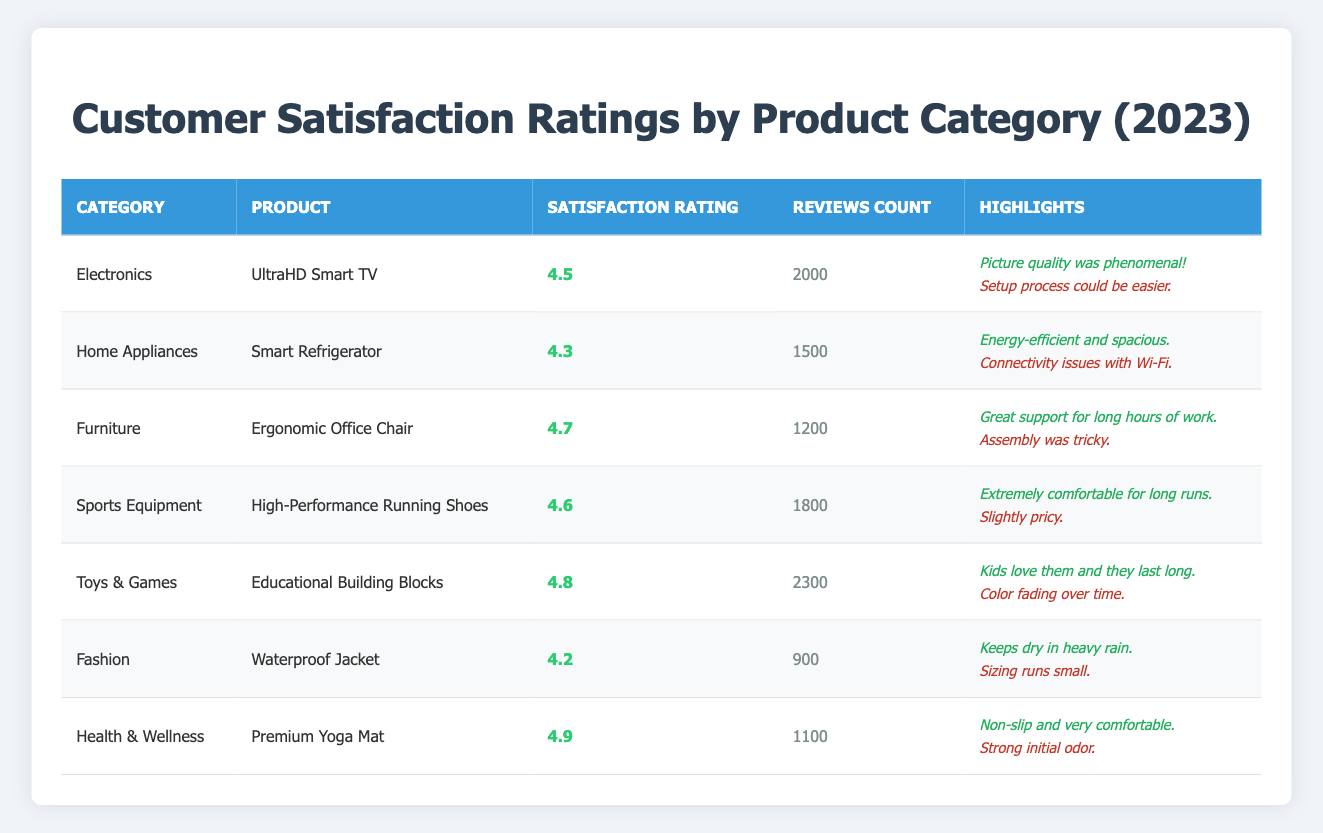What is the highest satisfaction rating among the products? The satisfaction ratings for the products are 4.5, 4.3, 4.7, 4.6, 4.8, 4.2, and 4.9. The highest of these is 4.9 for the Premium Yoga Mat.
Answer: 4.9 Which product has the lowest number of reviews? Looking at the Reviews Count column, the Waterproof Jacket has the lowest count with 900 reviews.
Answer: 900 What is the average satisfaction rating for all products? The satisfaction ratings are 4.5, 4.3, 4.7, 4.6, 4.8, 4.2, and 4.9. Summing these ratings gives 4.5 + 4.3 + 4.7 + 4.6 + 4.8 + 4.2 + 4.9 = 33.0. There are 7 ratings, so the average is 33.0 / 7 = 4.71.
Answer: 4.71 How many products have a satisfaction rating above 4.5? The products with ratings above 4.5 are: UltraHD Smart TV (4.5), Ergonomic Office Chair (4.7), High-Performance Running Shoes (4.6), Educational Building Blocks (4.8), and Premium Yoga Mat (4.9). That's a total of 5 products.
Answer: 5 Is the Smart Refrigerator rated higher than the Waterproof Jacket? The Smart Refrigerator has a satisfaction rating of 4.3, while the Waterproof Jacket has a rating of 4.2. Since 4.3 is greater than 4.2, the Smart Refrigerator is rated higher.
Answer: Yes What is the difference in satisfaction ratings between the product with the highest rating and the product with the lowest rating? The highest rating is 4.9 for the Premium Yoga Mat and the lowest rating is 4.2 for the Waterproof Jacket. The difference is 4.9 - 4.2 = 0.7.
Answer: 0.7 Which product has more than 2000 reviews? The only product that has more than 2000 reviews is the Educational Building Blocks with 2300 reviews.
Answer: Educational Building Blocks What is the positive feedback for the High-Performance Running Shoes? The positive feedback for the High-Performance Running Shoes is, "Extremely comfortable for long runs."
Answer: Extremely comfortable for long runs Are there more positive or negative feedback comments for the Ergonomic Office Chair? The Ergonomic Office Chair has one positive feedback ("Great support for long hours of work") and one negative feedback ("Assembly was tricky"), making it a tie.
Answer: Tie Which category did the Smart Refrigerator belong to? The Smart Refrigerator belongs to the Home Appliances category, as indicated in the Product Categories.
Answer: Home Appliances 